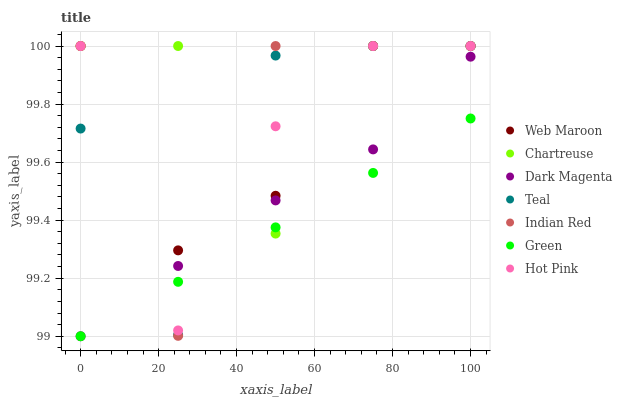Does Green have the minimum area under the curve?
Answer yes or no. Yes. Does Chartreuse have the maximum area under the curve?
Answer yes or no. Yes. Does Dark Magenta have the minimum area under the curve?
Answer yes or no. No. Does Dark Magenta have the maximum area under the curve?
Answer yes or no. No. Is Green the smoothest?
Answer yes or no. Yes. Is Indian Red the roughest?
Answer yes or no. Yes. Is Dark Magenta the smoothest?
Answer yes or no. No. Is Dark Magenta the roughest?
Answer yes or no. No. Does Dark Magenta have the lowest value?
Answer yes or no. Yes. Does Hot Pink have the lowest value?
Answer yes or no. No. Does Indian Red have the highest value?
Answer yes or no. Yes. Does Dark Magenta have the highest value?
Answer yes or no. No. Is Dark Magenta less than Web Maroon?
Answer yes or no. Yes. Is Web Maroon greater than Dark Magenta?
Answer yes or no. Yes. Does Hot Pink intersect Dark Magenta?
Answer yes or no. Yes. Is Hot Pink less than Dark Magenta?
Answer yes or no. No. Is Hot Pink greater than Dark Magenta?
Answer yes or no. No. Does Dark Magenta intersect Web Maroon?
Answer yes or no. No. 